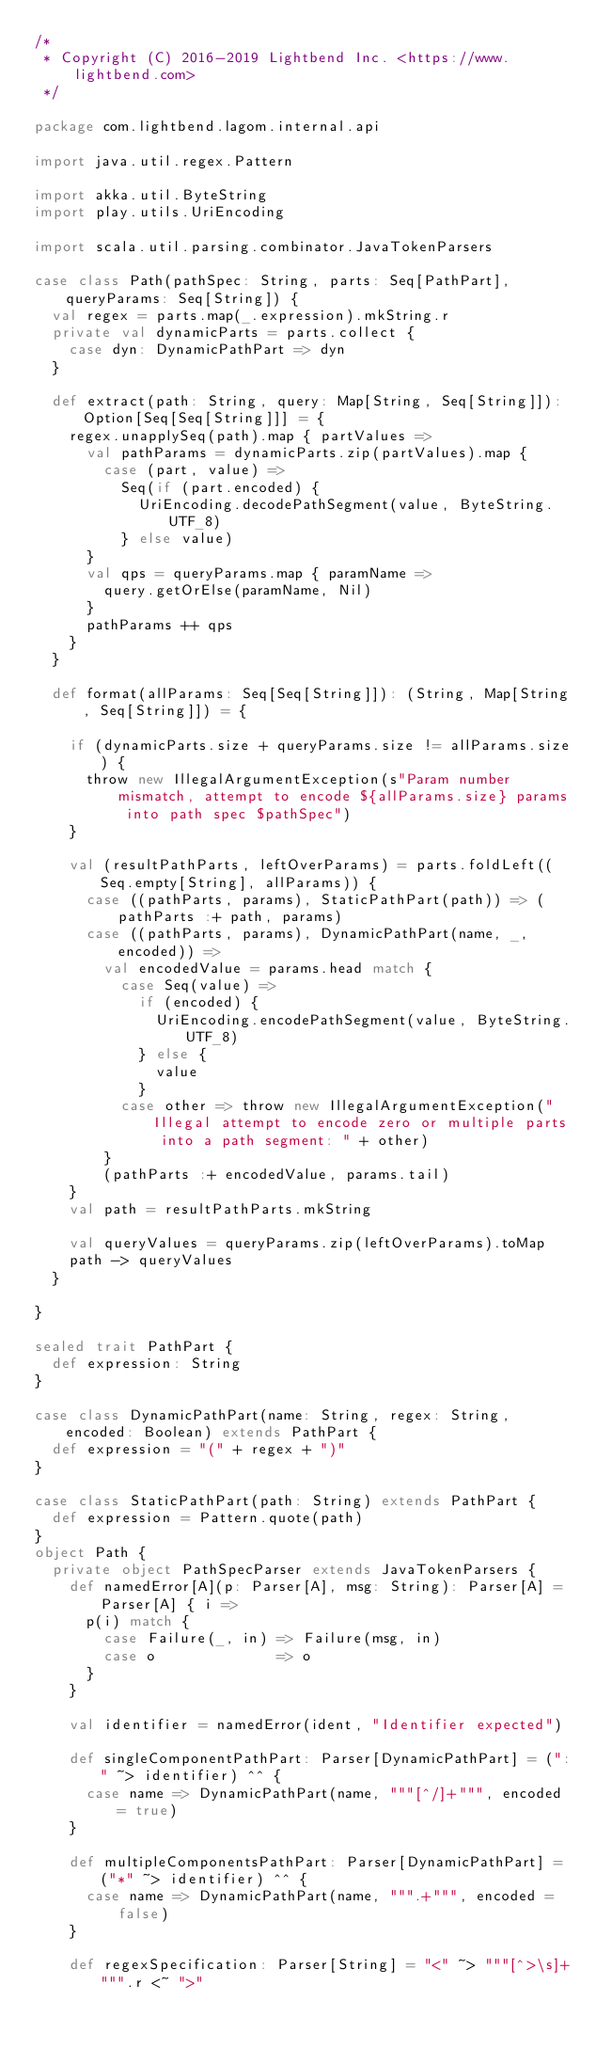<code> <loc_0><loc_0><loc_500><loc_500><_Scala_>/*
 * Copyright (C) 2016-2019 Lightbend Inc. <https://www.lightbend.com>
 */

package com.lightbend.lagom.internal.api

import java.util.regex.Pattern

import akka.util.ByteString
import play.utils.UriEncoding

import scala.util.parsing.combinator.JavaTokenParsers

case class Path(pathSpec: String, parts: Seq[PathPart], queryParams: Seq[String]) {
  val regex = parts.map(_.expression).mkString.r
  private val dynamicParts = parts.collect {
    case dyn: DynamicPathPart => dyn
  }

  def extract(path: String, query: Map[String, Seq[String]]): Option[Seq[Seq[String]]] = {
    regex.unapplySeq(path).map { partValues =>
      val pathParams = dynamicParts.zip(partValues).map {
        case (part, value) =>
          Seq(if (part.encoded) {
            UriEncoding.decodePathSegment(value, ByteString.UTF_8)
          } else value)
      }
      val qps = queryParams.map { paramName =>
        query.getOrElse(paramName, Nil)
      }
      pathParams ++ qps
    }
  }

  def format(allParams: Seq[Seq[String]]): (String, Map[String, Seq[String]]) = {

    if (dynamicParts.size + queryParams.size != allParams.size) {
      throw new IllegalArgumentException(s"Param number mismatch, attempt to encode ${allParams.size} params into path spec $pathSpec")
    }

    val (resultPathParts, leftOverParams) = parts.foldLeft((Seq.empty[String], allParams)) {
      case ((pathParts, params), StaticPathPart(path)) => (pathParts :+ path, params)
      case ((pathParts, params), DynamicPathPart(name, _, encoded)) =>
        val encodedValue = params.head match {
          case Seq(value) =>
            if (encoded) {
              UriEncoding.encodePathSegment(value, ByteString.UTF_8)
            } else {
              value
            }
          case other => throw new IllegalArgumentException("Illegal attempt to encode zero or multiple parts into a path segment: " + other)
        }
        (pathParts :+ encodedValue, params.tail)
    }
    val path = resultPathParts.mkString

    val queryValues = queryParams.zip(leftOverParams).toMap
    path -> queryValues
  }

}

sealed trait PathPart {
  def expression: String
}

case class DynamicPathPart(name: String, regex: String, encoded: Boolean) extends PathPart {
  def expression = "(" + regex + ")"
}

case class StaticPathPart(path: String) extends PathPart {
  def expression = Pattern.quote(path)
}
object Path {
  private object PathSpecParser extends JavaTokenParsers {
    def namedError[A](p: Parser[A], msg: String): Parser[A] = Parser[A] { i =>
      p(i) match {
        case Failure(_, in) => Failure(msg, in)
        case o              => o
      }
    }

    val identifier = namedError(ident, "Identifier expected")

    def singleComponentPathPart: Parser[DynamicPathPart] = (":" ~> identifier) ^^ {
      case name => DynamicPathPart(name, """[^/]+""", encoded = true)
    }

    def multipleComponentsPathPart: Parser[DynamicPathPart] = ("*" ~> identifier) ^^ {
      case name => DynamicPathPart(name, """.+""", encoded = false)
    }

    def regexSpecification: Parser[String] = "<" ~> """[^>\s]+""".r <~ ">"
</code> 